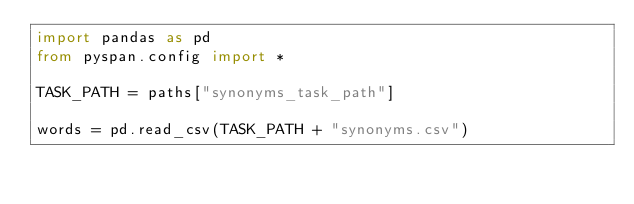Convert code to text. <code><loc_0><loc_0><loc_500><loc_500><_Python_>import pandas as pd
from pyspan.config import *

TASK_PATH = paths["synonyms_task_path"]

words = pd.read_csv(TASK_PATH + "synonyms.csv")
</code> 